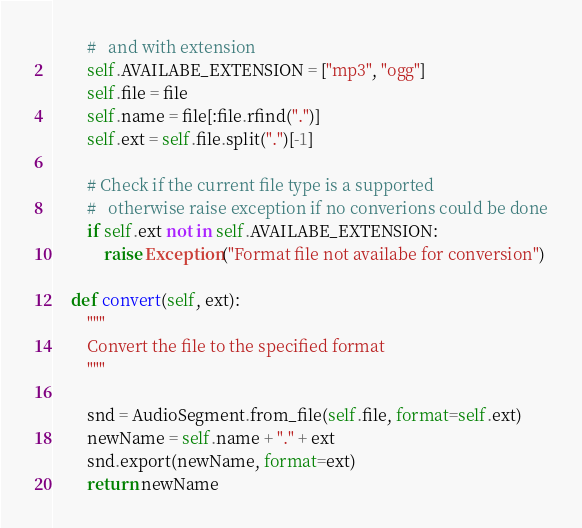<code> <loc_0><loc_0><loc_500><loc_500><_Python_>        #   and with extension
        self.AVAILABE_EXTENSION = ["mp3", "ogg"]
        self.file = file
        self.name = file[:file.rfind(".")]
        self.ext = self.file.split(".")[-1]

        # Check if the current file type is a supported
        #   otherwise raise exception if no converions could be done
        if self.ext not in self.AVAILABE_EXTENSION:
            raise Exception("Format file not availabe for conversion")

    def convert(self, ext):
        """
        Convert the file to the specified format
        """

        snd = AudioSegment.from_file(self.file, format=self.ext)
        newName = self.name + "." + ext
        snd.export(newName, format=ext)
        return newName
</code> 